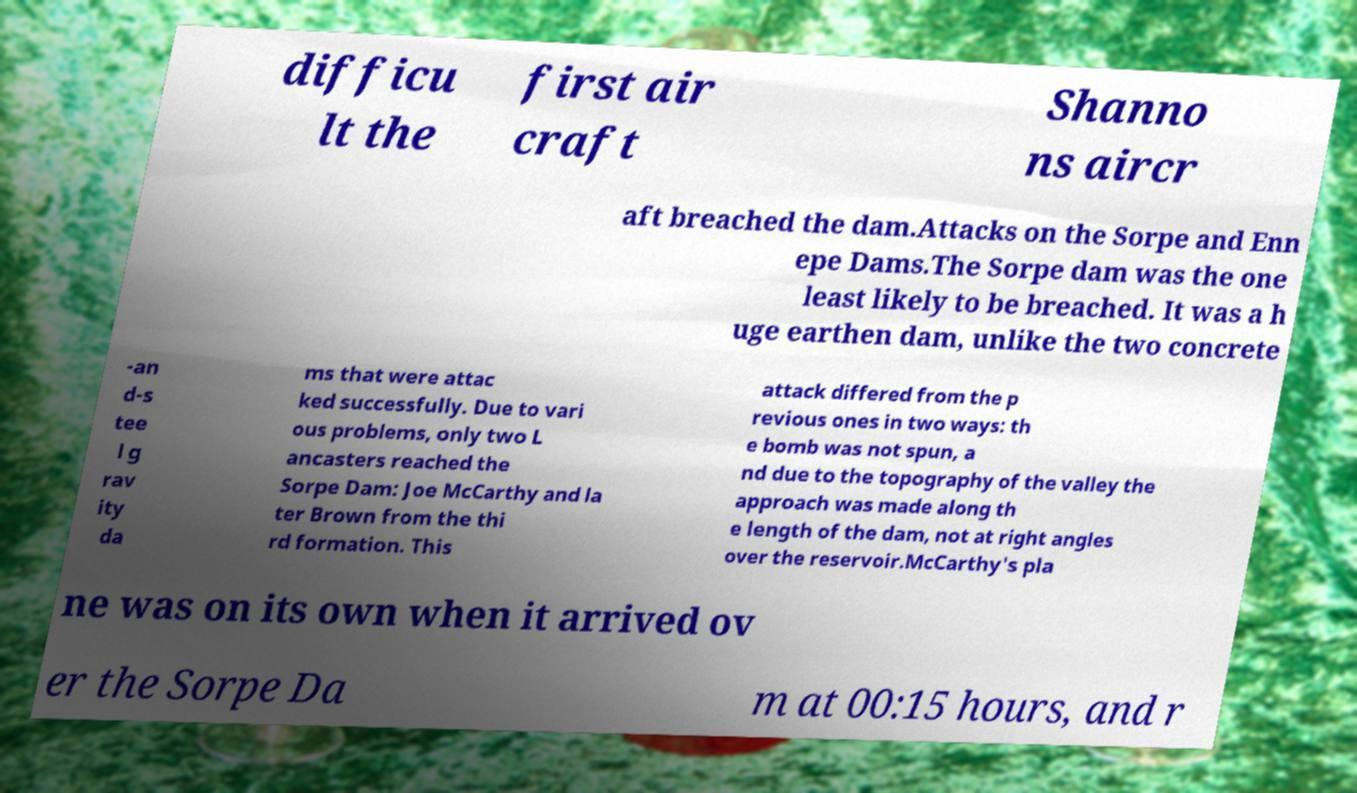Please read and relay the text visible in this image. What does it say? difficu lt the first air craft Shanno ns aircr aft breached the dam.Attacks on the Sorpe and Enn epe Dams.The Sorpe dam was the one least likely to be breached. It was a h uge earthen dam, unlike the two concrete -an d-s tee l g rav ity da ms that were attac ked successfully. Due to vari ous problems, only two L ancasters reached the Sorpe Dam: Joe McCarthy and la ter Brown from the thi rd formation. This attack differed from the p revious ones in two ways: th e bomb was not spun, a nd due to the topography of the valley the approach was made along th e length of the dam, not at right angles over the reservoir.McCarthy's pla ne was on its own when it arrived ov er the Sorpe Da m at 00:15 hours, and r 